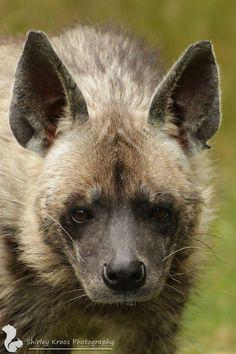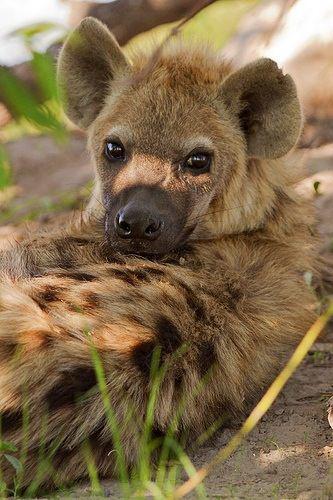The first image is the image on the left, the second image is the image on the right. Given the left and right images, does the statement "The images contain a total of one open-mouthed hyena baring fangs." hold true? Answer yes or no. No. 